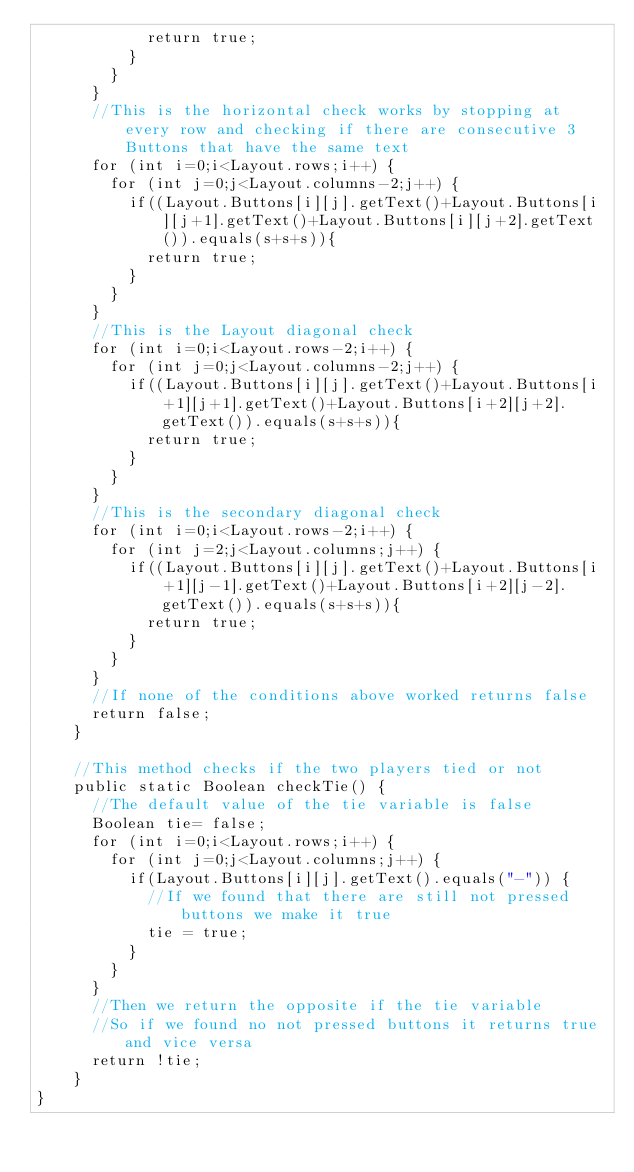Convert code to text. <code><loc_0><loc_0><loc_500><loc_500><_Java_>						return true;
					}
				}
			}
			//This is the horizontal check works by stopping at every row and checking if there are consecutive 3 Buttons that have the same text
			for (int i=0;i<Layout.rows;i++) {
				for (int j=0;j<Layout.columns-2;j++) {
					if((Layout.Buttons[i][j].getText()+Layout.Buttons[i][j+1].getText()+Layout.Buttons[i][j+2].getText()).equals(s+s+s)){
						return true;
					}
				}
			}
			//This is the Layout diagonal check
			for (int i=0;i<Layout.rows-2;i++) {
				for (int j=0;j<Layout.columns-2;j++) {
					if((Layout.Buttons[i][j].getText()+Layout.Buttons[i+1][j+1].getText()+Layout.Buttons[i+2][j+2].getText()).equals(s+s+s)){
						return true;
					}
				}
			}
			//This is the secondary diagonal check
			for (int i=0;i<Layout.rows-2;i++) {
				for (int j=2;j<Layout.columns;j++) {
					if((Layout.Buttons[i][j].getText()+Layout.Buttons[i+1][j-1].getText()+Layout.Buttons[i+2][j-2].getText()).equals(s+s+s)){
						return true;
					}
				}
			}
			//If none of the conditions above worked returns false
			return false;
		}
		
		//This method checks if the two players tied or not
		public static Boolean checkTie() {
			//The default value of the tie variable is false
			Boolean tie= false;
			for (int i=0;i<Layout.rows;i++) {
				for (int j=0;j<Layout.columns;j++) {
					if(Layout.Buttons[i][j].getText().equals("-")) {
						//If we found that there are still not pressed buttons we make it true
						tie = true;
					}
				}
			}
			//Then we return the opposite if the tie variable
			//So if we found no not pressed buttons it returns true and vice versa
			return !tie;
		}
}
</code> 